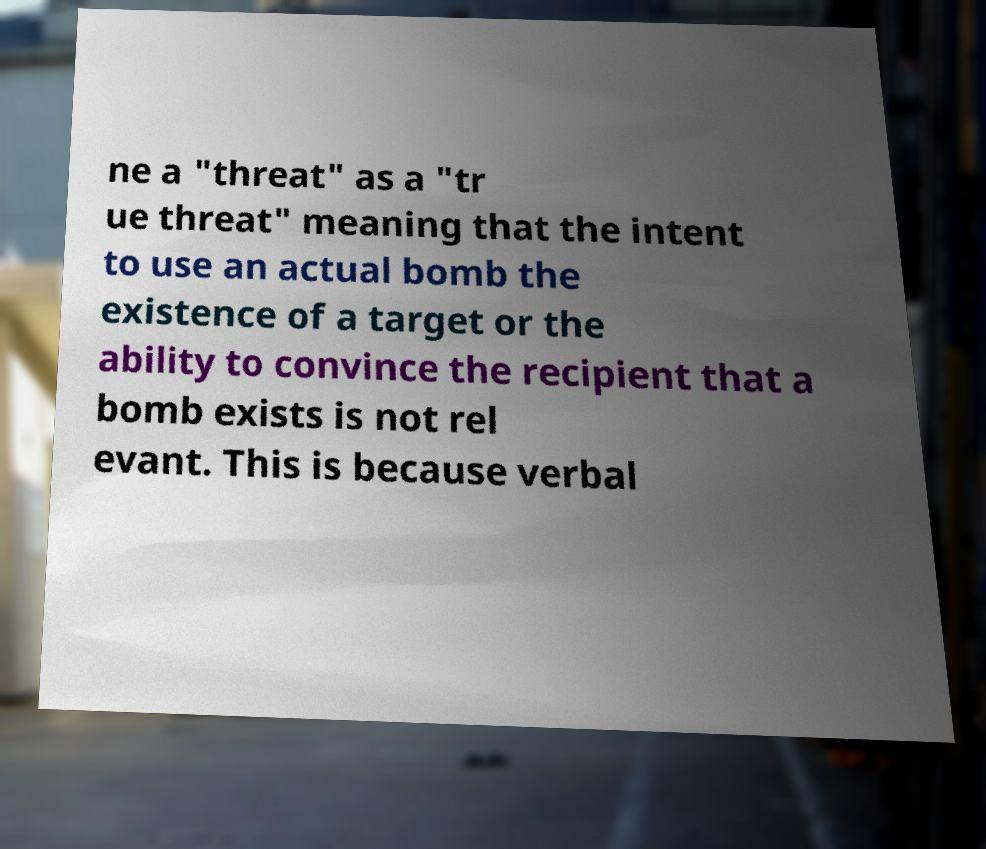Can you accurately transcribe the text from the provided image for me? ne a "threat" as a "tr ue threat" meaning that the intent to use an actual bomb the existence of a target or the ability to convince the recipient that a bomb exists is not rel evant. This is because verbal 